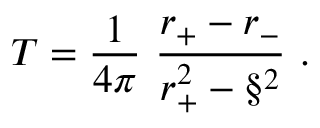Convert formula to latex. <formula><loc_0><loc_0><loc_500><loc_500>T = \frac { 1 } { 4 \pi } \ \frac { r _ { + } - r _ { - } } { r _ { + } ^ { 2 } - \S ^ { 2 } } \ .</formula> 